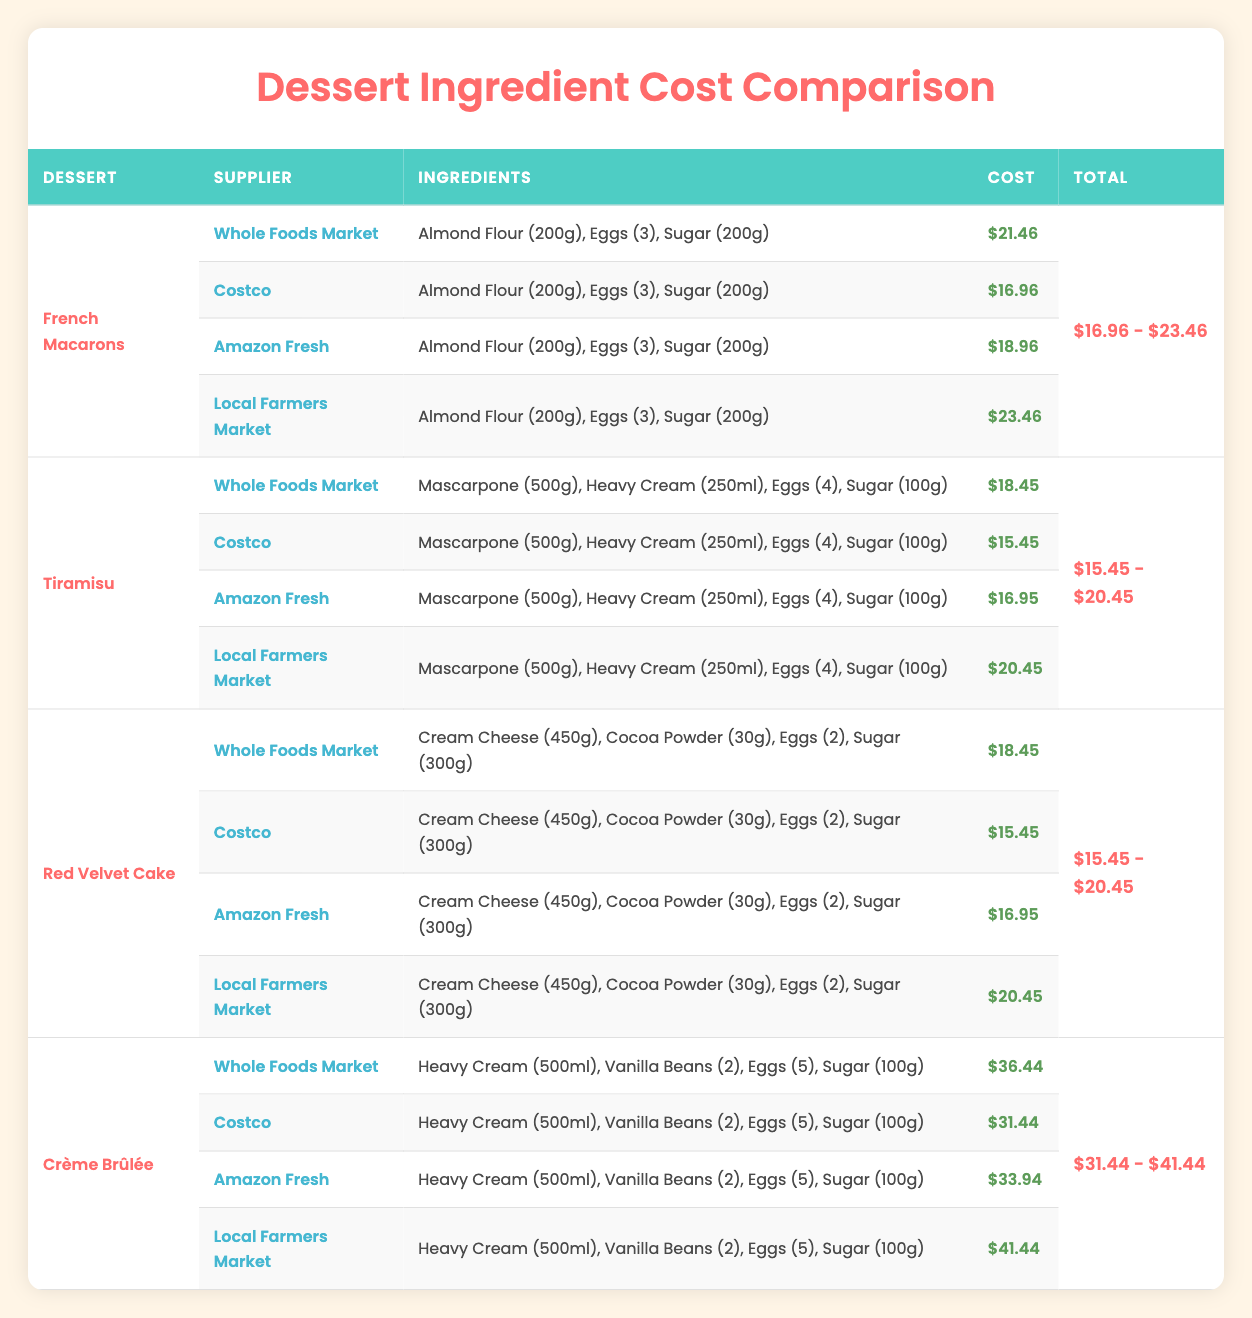What is the cheapest supplier for Almond Flour? Looking at the prices for Almond Flour from different suppliers, Costco offers Almond Flour at $9.99, which is the lowest compared to Whole Foods Market at $12.99, Amazon Fresh at $11.49, and Local Farmers Market at $13.99.
Answer: Costco Which dessert has the highest cost when purchased from Whole Foods Market? From the table, we can see the total costs for the desserts when purchased from Whole Foods Market: French Macarons $21.46, Tiramisu $18.45, Red Velvet Cake $18.45, and Crème Brûlée $36.44. The highest cost is for Crème Brûlée at $36.44.
Answer: Crème Brûlée What is the total cost of ingredients for Tiramisu from Costco? The prices for Tiramisu ingredients from Costco are: Mascarpone at $4.99, Heavy Cream at $3.99, Eggs at $3.49, and Sugar at $2.99. Adding these costs together: 4.99 + 3.99 + 3.49 + 2.99 equals $15.45.
Answer: $15.45 Is the cost of Heavy Cream from Local Farmers Market lower than that from Whole Foods Market? The price of Heavy Cream from Local Farmers Market is $5.49, while from Whole Foods Market it is $4.99. Since $5.49 is greater than $4.99, the statement is false.
Answer: No What is the difference in cost for Cream Cheese between the cheapest and most expensive suppliers? The cheapest Cream Cheese is from Costco at $2.99, and the most expensive is from Whole Foods Market at $3.49. The difference between them is calculated as $3.49 - $2.99 which equals $0.50.
Answer: $0.50 Which dessert has the widest price range across all suppliers? By examining the total costs for each dessert: French Macarons ranges from $16.96 to $23.46 ($6.50 range), Tiramisu from $15.45 to $20.45 ($5.00 range), Red Velvet Cake from $15.45 to $20.45 ($5.00 range), and Crème Brûlée from $31.44 to $41.44 ($10.00 range). Crème Brûlée has the widest price range of $10.00.
Answer: Crème Brûlée 